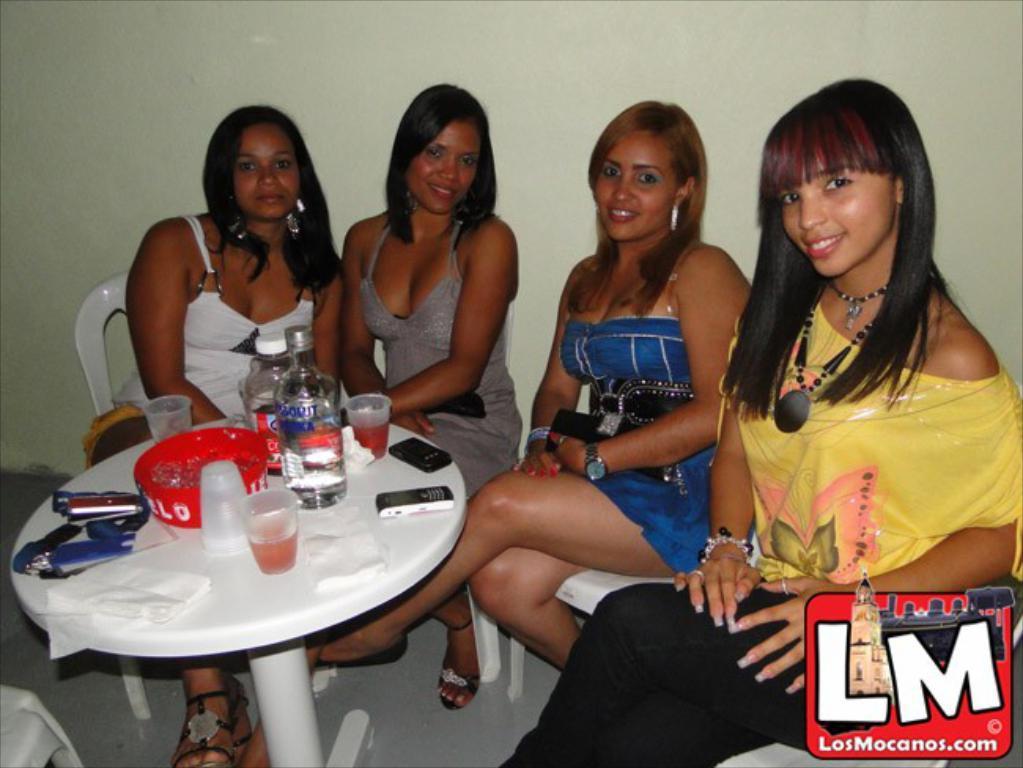How would you summarize this image in a sentence or two? In this picture we can see four women sitting on chairs and smiling and in front of them there is table and on table we can see glass, mobile, bottle, bowl and in background we can see wall. 